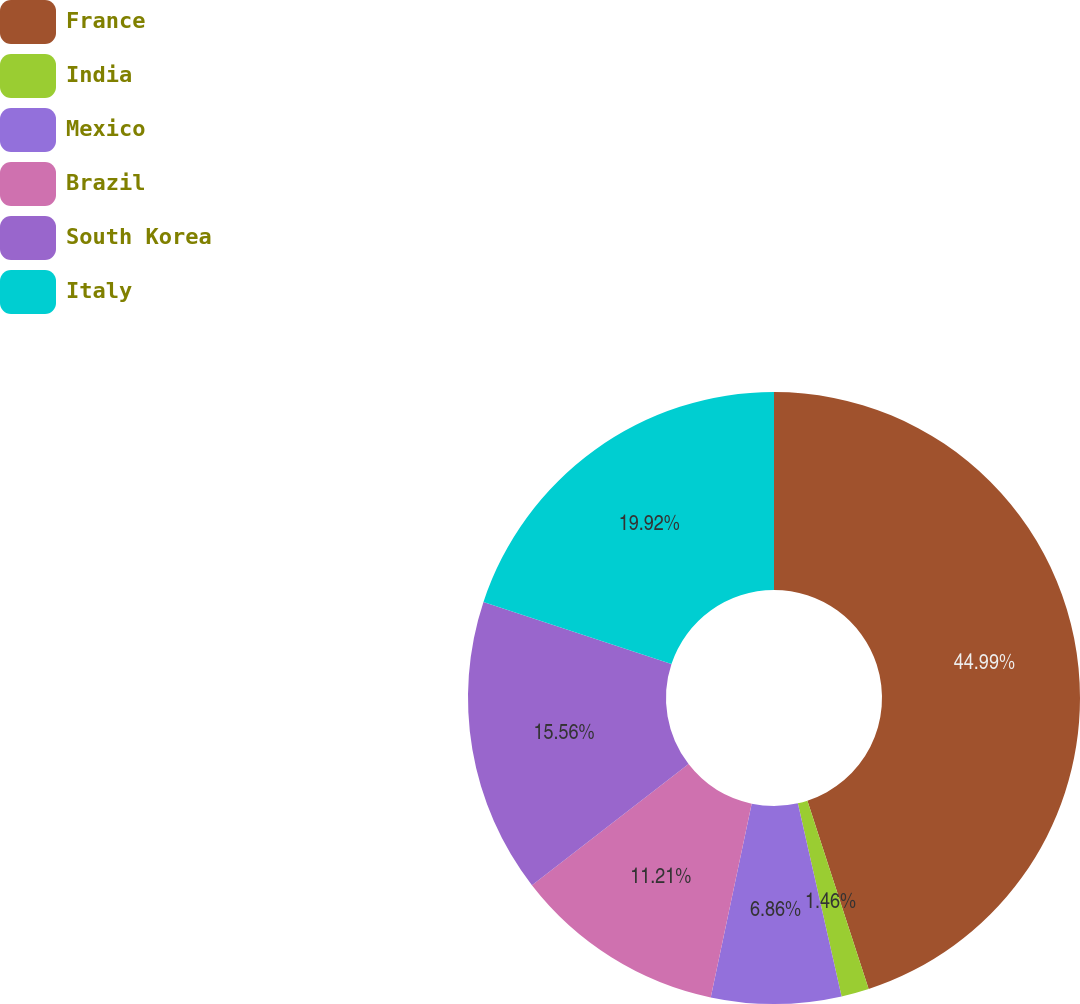Convert chart to OTSL. <chart><loc_0><loc_0><loc_500><loc_500><pie_chart><fcel>France<fcel>India<fcel>Mexico<fcel>Brazil<fcel>South Korea<fcel>Italy<nl><fcel>45.0%<fcel>1.46%<fcel>6.86%<fcel>11.21%<fcel>15.56%<fcel>19.92%<nl></chart> 